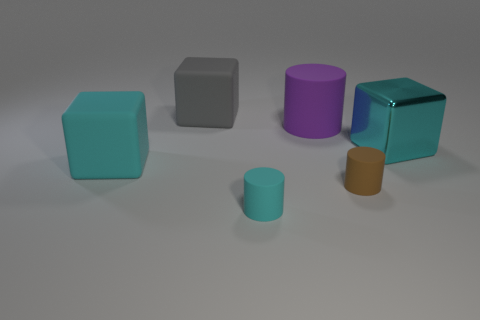Add 2 small brown things. How many objects exist? 8 Subtract 0 brown spheres. How many objects are left? 6 Subtract all big matte things. Subtract all purple things. How many objects are left? 2 Add 3 small brown objects. How many small brown objects are left? 4 Add 1 cyan shiny things. How many cyan shiny things exist? 2 